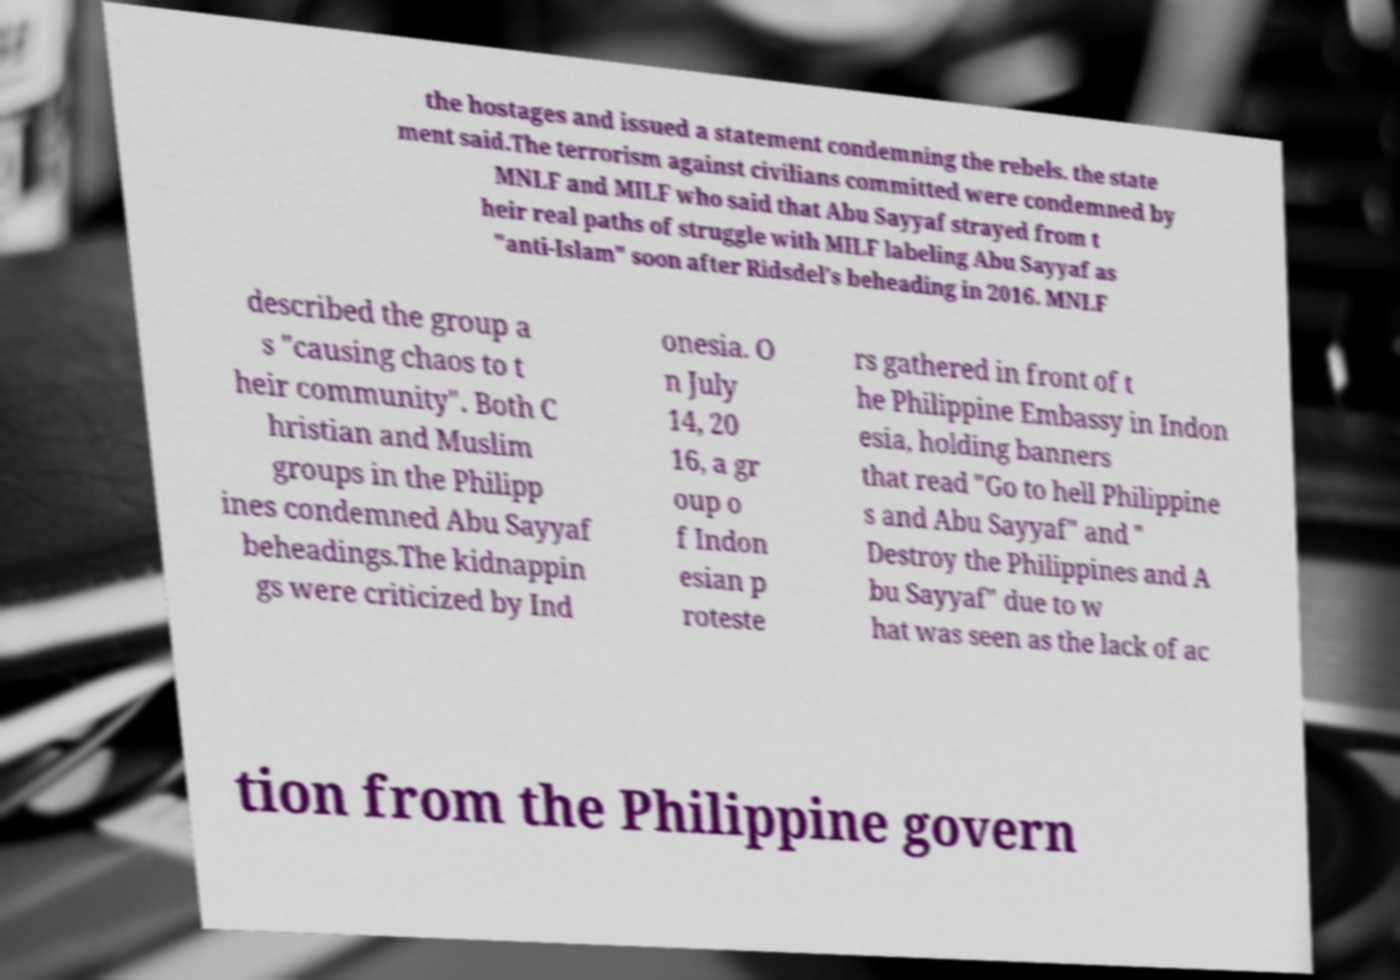Can you accurately transcribe the text from the provided image for me? the hostages and issued a statement condemning the rebels. the state ment said.The terrorism against civilians committed were condemned by MNLF and MILF who said that Abu Sayyaf strayed from t heir real paths of struggle with MILF labeling Abu Sayyaf as "anti-Islam" soon after Ridsdel's beheading in 2016. MNLF described the group a s "causing chaos to t heir community". Both C hristian and Muslim groups in the Philipp ines condemned Abu Sayyaf beheadings.The kidnappin gs were criticized by Ind onesia. O n July 14, 20 16, a gr oup o f Indon esian p roteste rs gathered in front of t he Philippine Embassy in Indon esia, holding banners that read "Go to hell Philippine s and Abu Sayyaf" and " Destroy the Philippines and A bu Sayyaf" due to w hat was seen as the lack of ac tion from the Philippine govern 